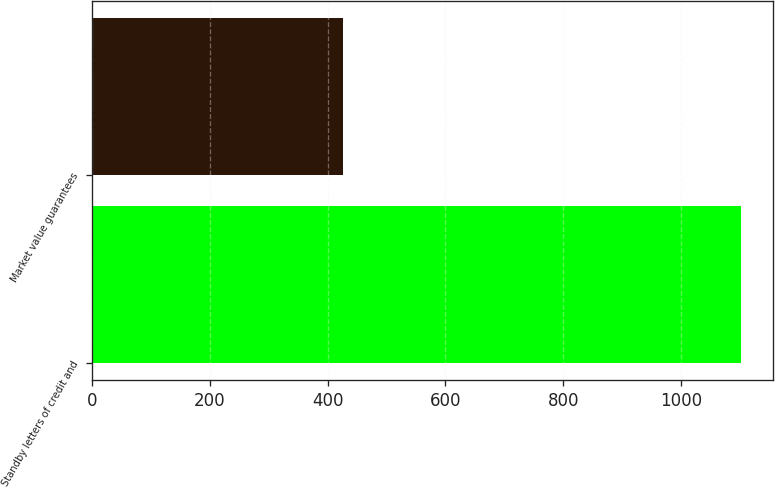Convert chart. <chart><loc_0><loc_0><loc_500><loc_500><bar_chart><fcel>Standby letters of credit and<fcel>Market value guarantees<nl><fcel>1102<fcel>426<nl></chart> 